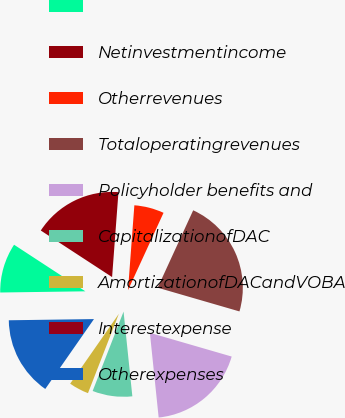<chart> <loc_0><loc_0><loc_500><loc_500><pie_chart><ecel><fcel>Netinvestmentincome<fcel>Otherrevenues<fcel>Totaloperatingrevenues<fcel>Policyholder benefits and<fcel>CapitalizationofDAC<fcel>AmortizationofDACandVOBA<fcel>Interestexpense<fcel>Otherexpenses<nl><fcel>9.43%<fcel>16.98%<fcel>5.66%<fcel>22.64%<fcel>18.86%<fcel>7.55%<fcel>3.78%<fcel>0.0%<fcel>15.09%<nl></chart> 